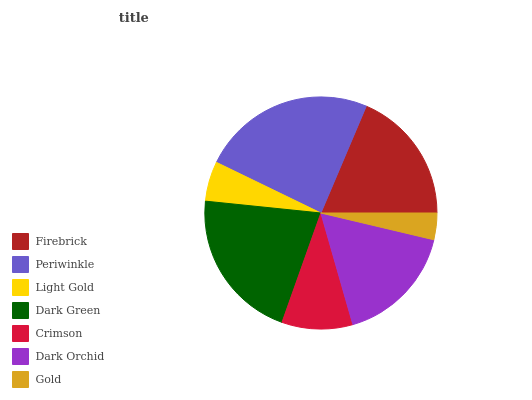Is Gold the minimum?
Answer yes or no. Yes. Is Periwinkle the maximum?
Answer yes or no. Yes. Is Light Gold the minimum?
Answer yes or no. No. Is Light Gold the maximum?
Answer yes or no. No. Is Periwinkle greater than Light Gold?
Answer yes or no. Yes. Is Light Gold less than Periwinkle?
Answer yes or no. Yes. Is Light Gold greater than Periwinkle?
Answer yes or no. No. Is Periwinkle less than Light Gold?
Answer yes or no. No. Is Dark Orchid the high median?
Answer yes or no. Yes. Is Dark Orchid the low median?
Answer yes or no. Yes. Is Firebrick the high median?
Answer yes or no. No. Is Light Gold the low median?
Answer yes or no. No. 